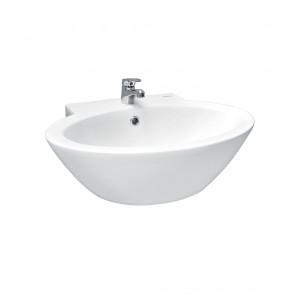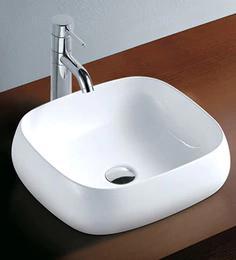The first image is the image on the left, the second image is the image on the right. Examine the images to the left and right. Is the description "The drain hole is visible in only one image." accurate? Answer yes or no. Yes. 